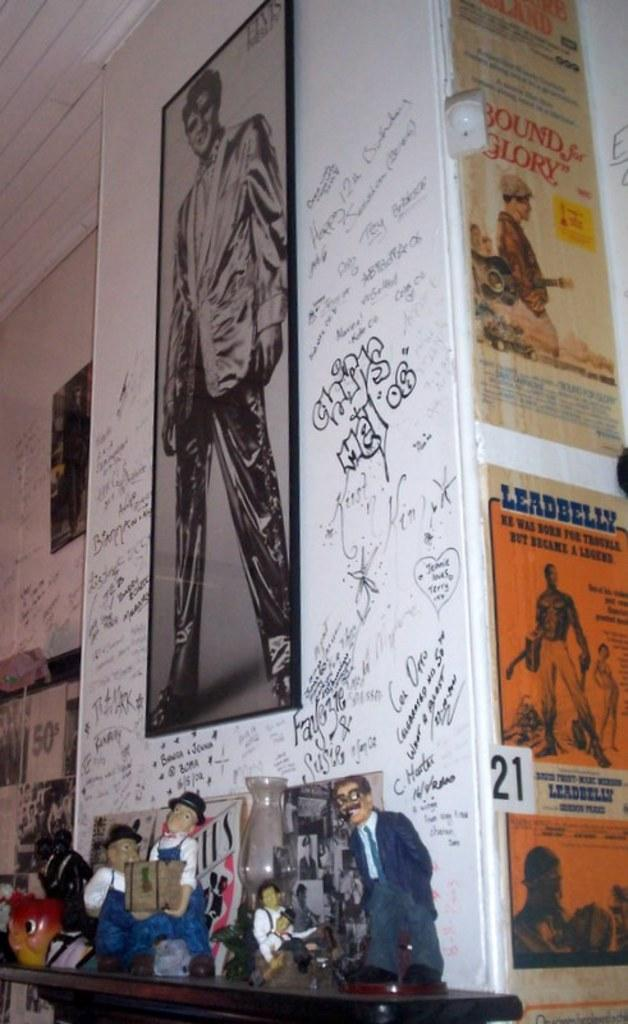<image>
Provide a brief description of the given image. A large poster of Elvis Presley is surrounded by graffti and a puppet display at his feet. 